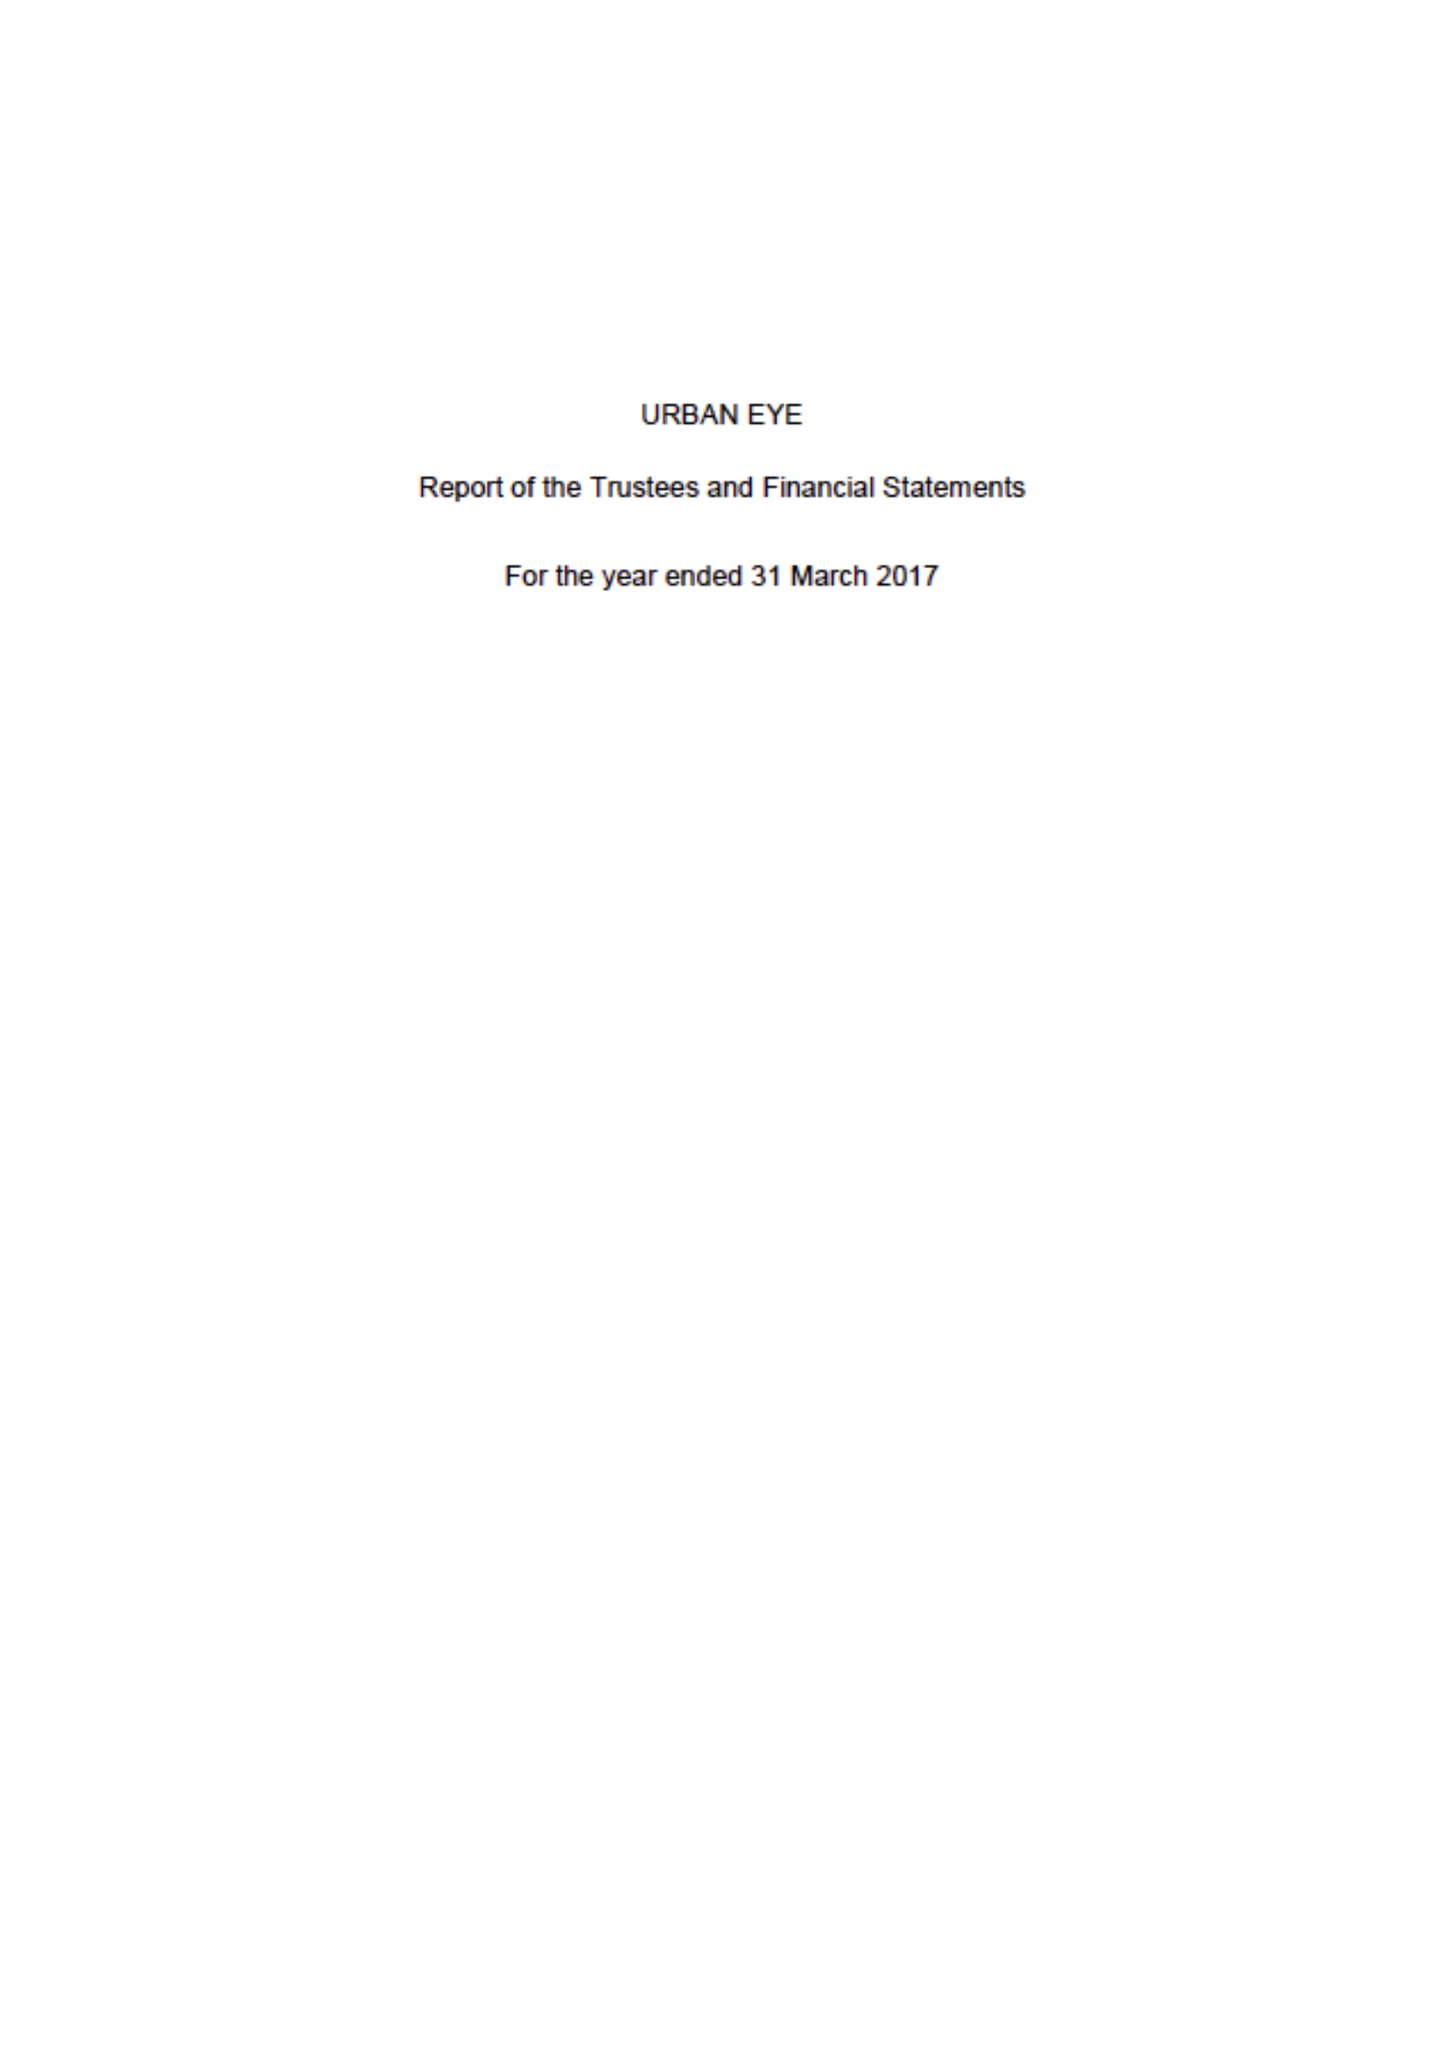What is the value for the charity_number?
Answer the question using a single word or phrase. 1089336 